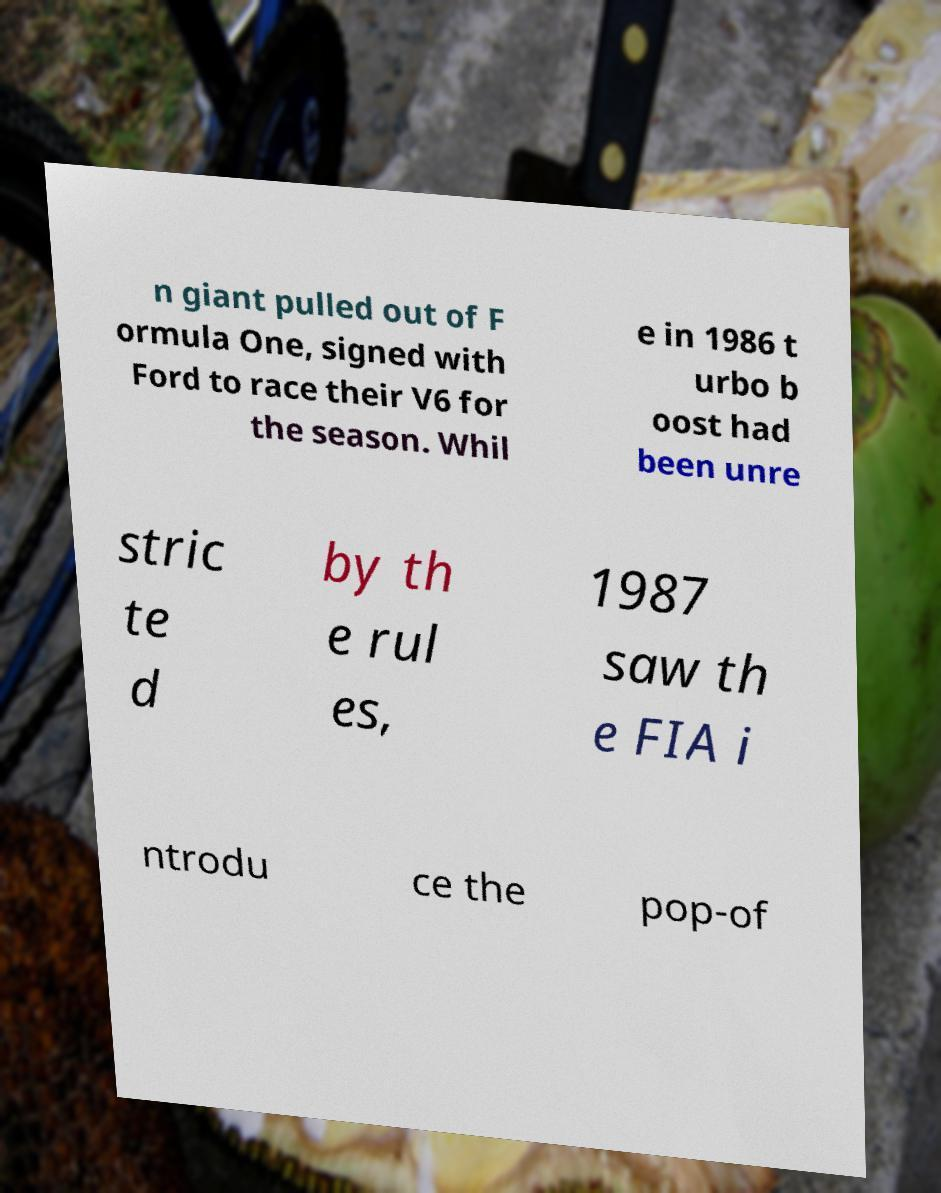Can you accurately transcribe the text from the provided image for me? n giant pulled out of F ormula One, signed with Ford to race their V6 for the season. Whil e in 1986 t urbo b oost had been unre stric te d by th e rul es, 1987 saw th e FIA i ntrodu ce the pop-of 